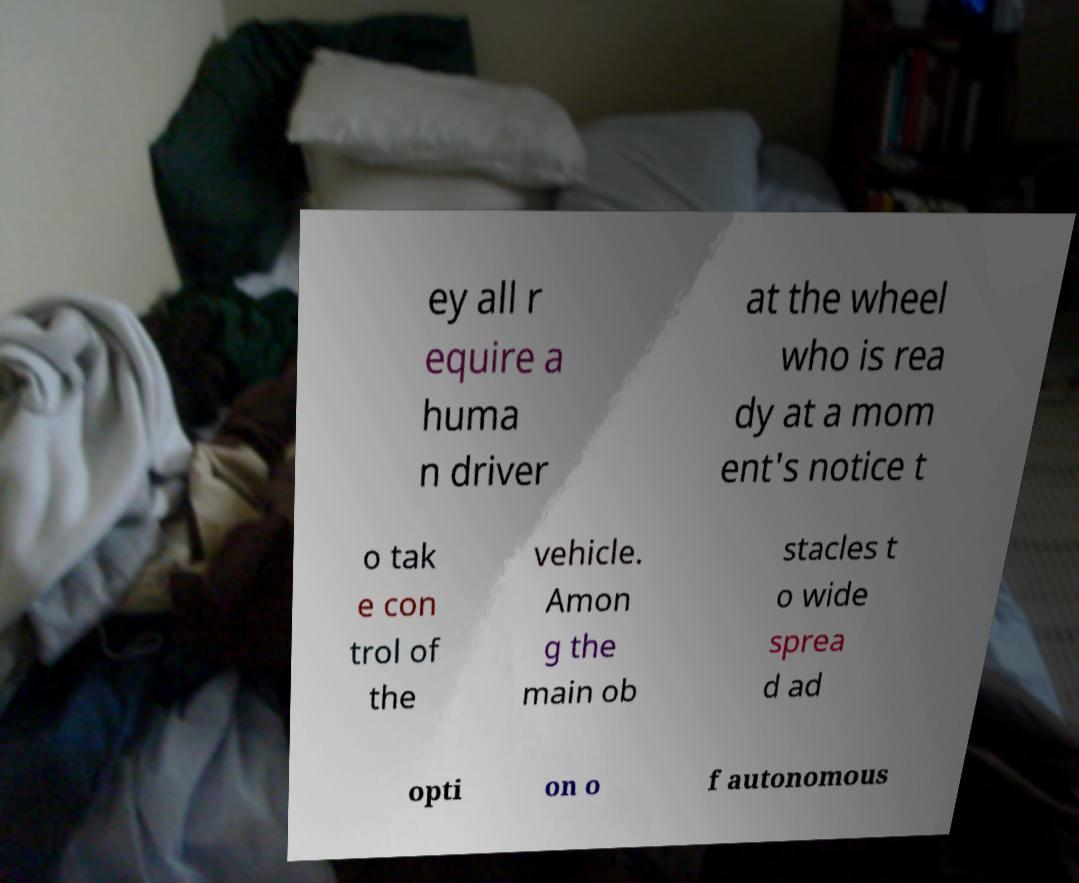Could you extract and type out the text from this image? ey all r equire a huma n driver at the wheel who is rea dy at a mom ent's notice t o tak e con trol of the vehicle. Amon g the main ob stacles t o wide sprea d ad opti on o f autonomous 